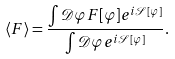Convert formula to latex. <formula><loc_0><loc_0><loc_500><loc_500>\langle F \rangle = { \frac { \int { \mathcal { D } } \varphi F [ \varphi ] e ^ { i { \mathcal { S } } [ \varphi ] } } { \int { \mathcal { D } } \varphi e ^ { i { \mathcal { S } } [ \varphi ] } } } .</formula> 